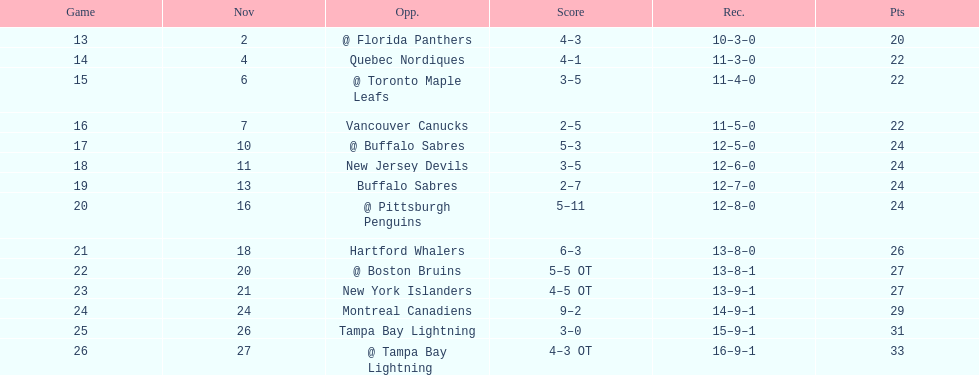Were the new jersey devils in last place according to the chart? No. 